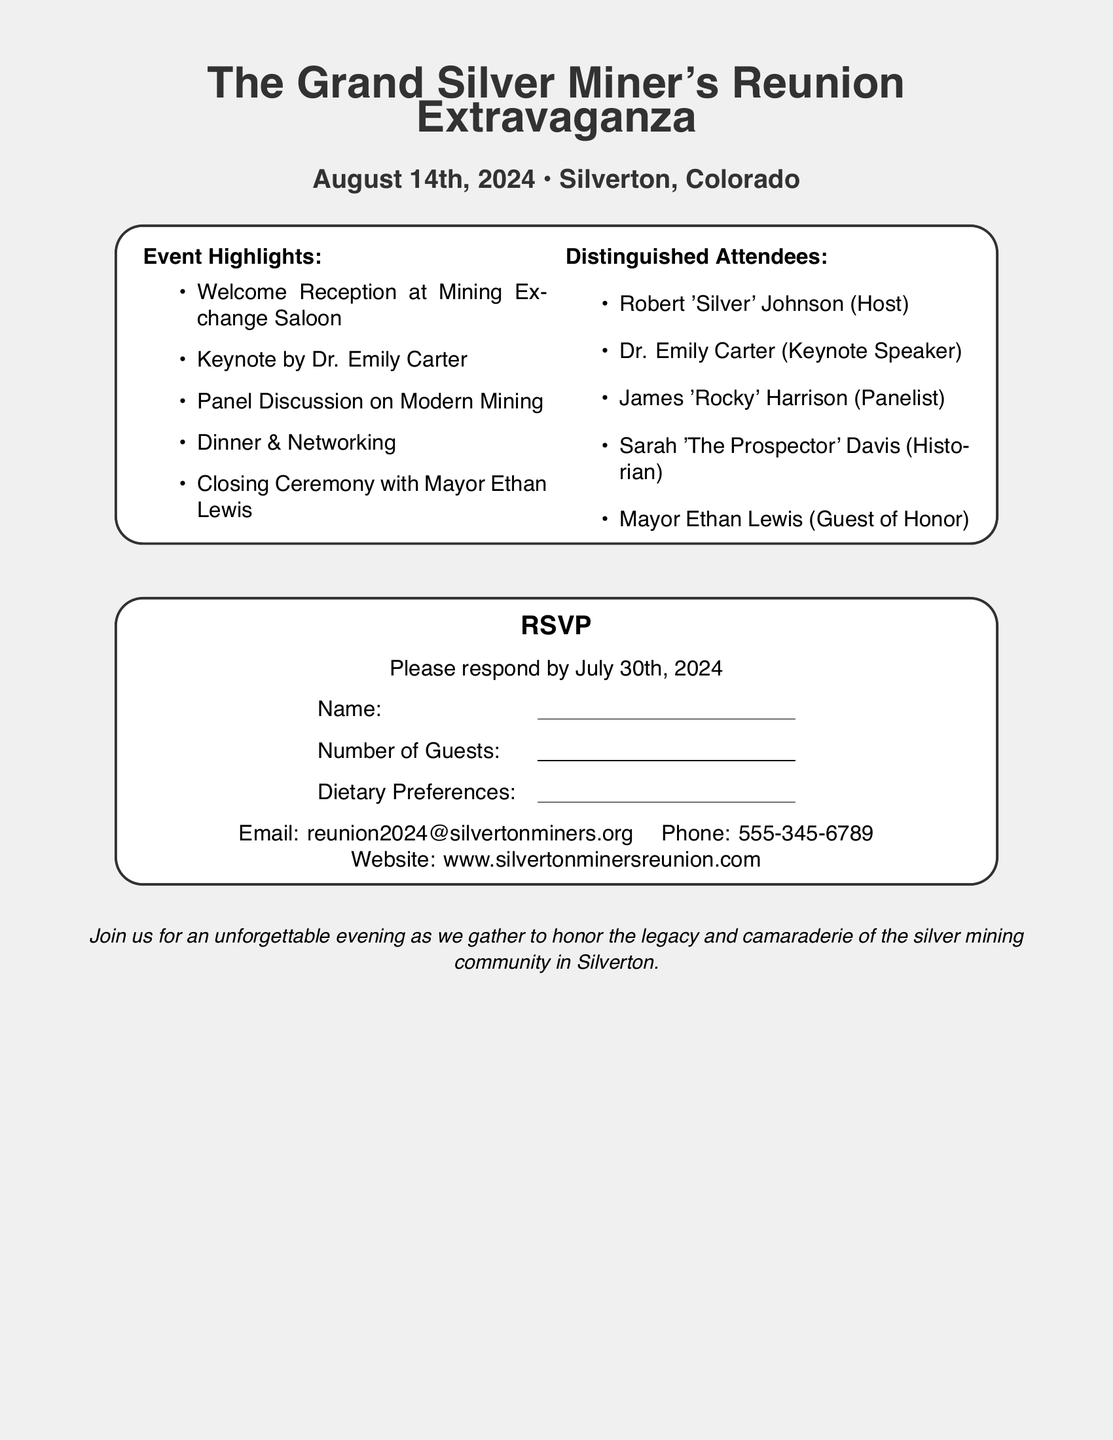what is the date of the event? The date of the event is specified in the document as August 14th, 2024.
Answer: August 14th, 2024 who is the host of the reunion? The host of the reunion is listed in the document as Robert 'Silver' Johnson.
Answer: Robert 'Silver' Johnson what is the email address for RSVP? The email address for RSVP is provided in the document as reunion2024@silvertonminers.org.
Answer: reunion2024@silvertonminers.org how many distinguished attendees are listed? The document lists five distinguished attendees, which can be counted from the relevant section.
Answer: five what will happen during the closing ceremony? The document indicates that the closing ceremony will include Mayor Ethan Lewis as the Guest of Honor, requiring reasoning about the events schedule.
Answer: Mayor Ethan Lewis what is the last date to RSVP? The document specifies that RSVP responses must be submitted by July 30th, 2024.
Answer: July 30th, 2024 where will the welcome reception take place? The welcome reception is stated to take place at Mining Exchange Saloon, based on the event details in the document.
Answer: Mining Exchange Saloon who is the keynote speaker? According to the document, the keynote speaker for the event is Dr. Emily Carter.
Answer: Dr. Emily Carter 